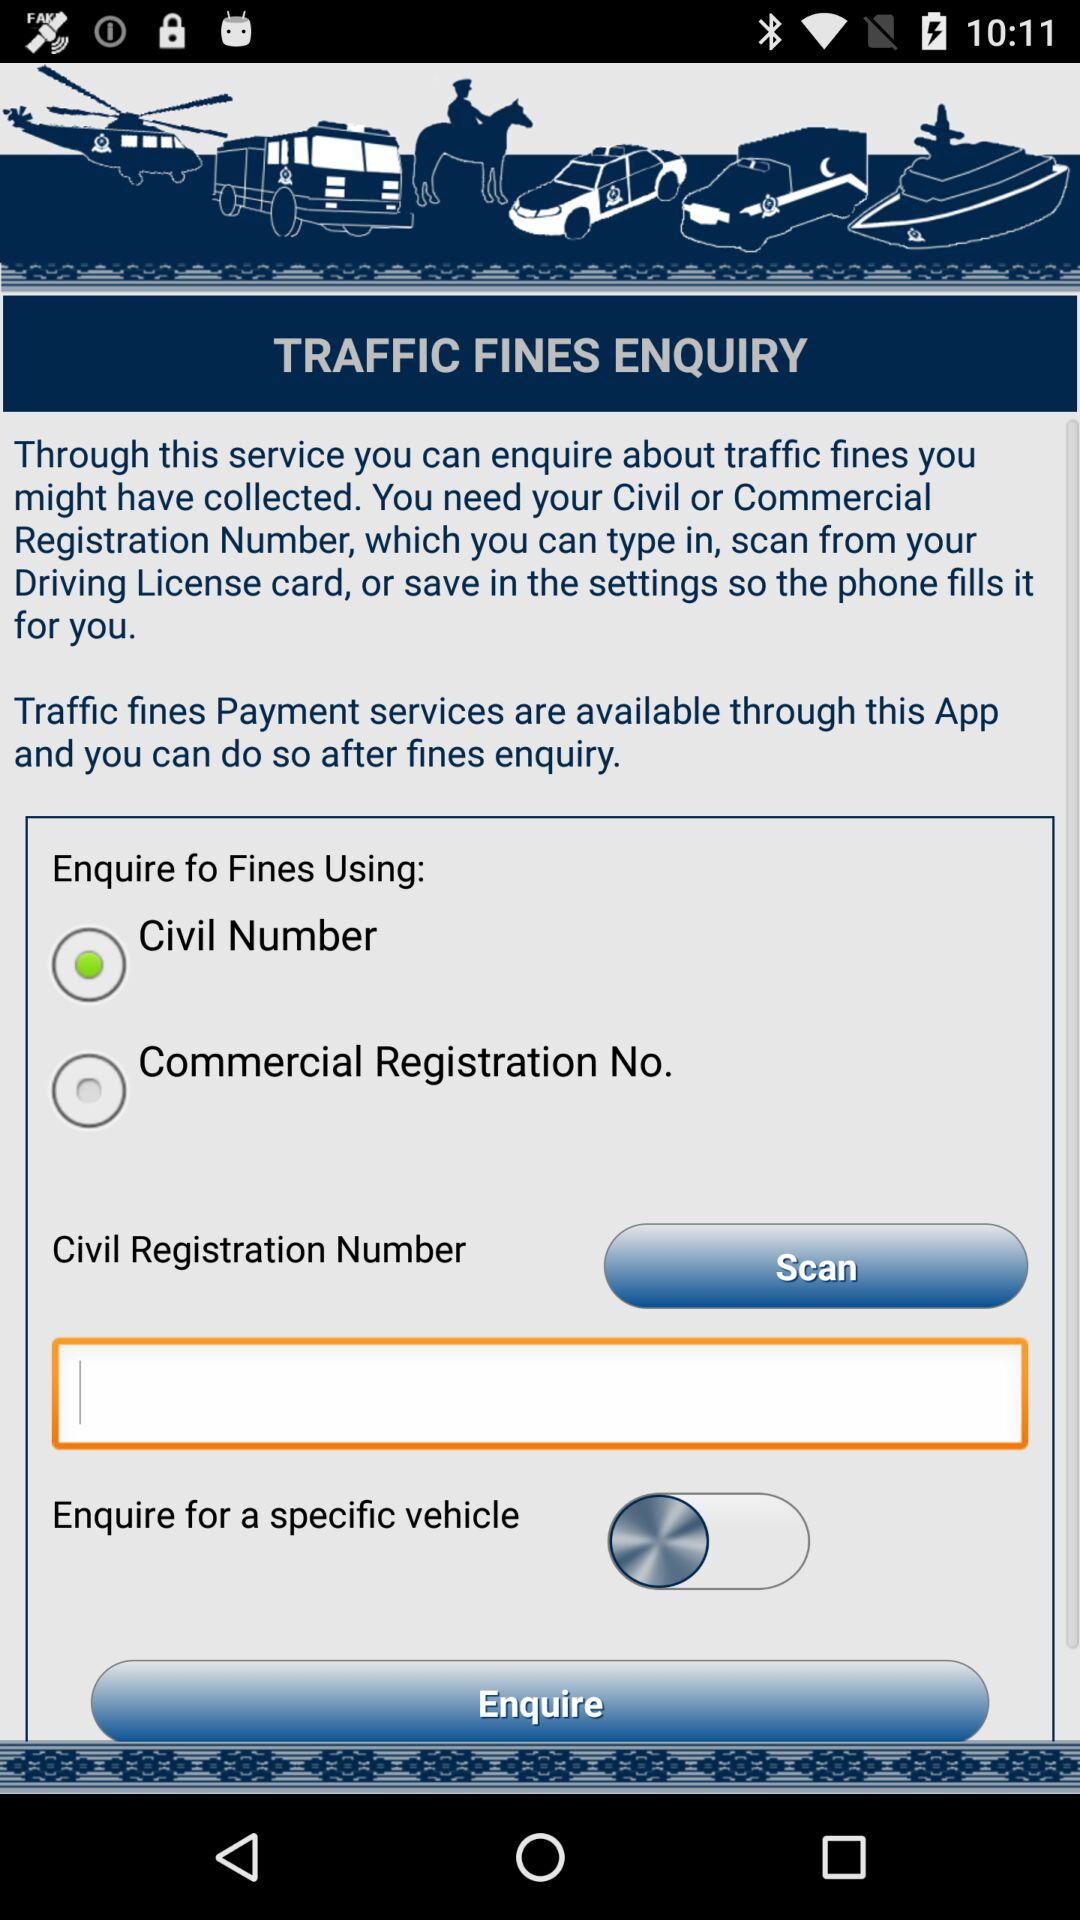What is the status of "Enquire for a specific vehicle"? The status is "off". 